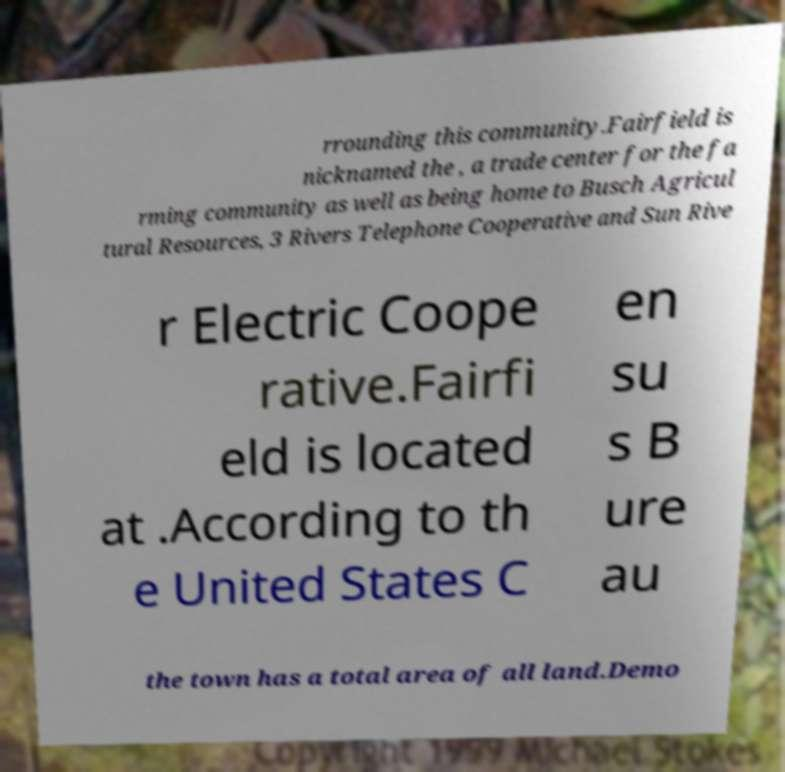What messages or text are displayed in this image? I need them in a readable, typed format. rrounding this community.Fairfield is nicknamed the , a trade center for the fa rming community as well as being home to Busch Agricul tural Resources, 3 Rivers Telephone Cooperative and Sun Rive r Electric Coope rative.Fairfi eld is located at .According to th e United States C en su s B ure au the town has a total area of all land.Demo 